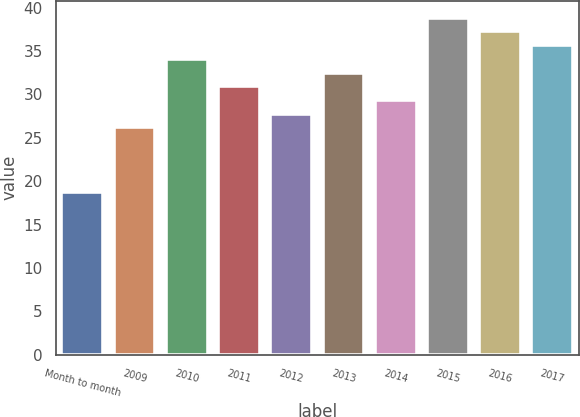Convert chart to OTSL. <chart><loc_0><loc_0><loc_500><loc_500><bar_chart><fcel>Month to month<fcel>2009<fcel>2010<fcel>2011<fcel>2012<fcel>2013<fcel>2014<fcel>2015<fcel>2016<fcel>2017<nl><fcel>18.77<fcel>26.19<fcel>34.09<fcel>30.93<fcel>27.77<fcel>32.51<fcel>29.35<fcel>38.83<fcel>37.25<fcel>35.67<nl></chart> 